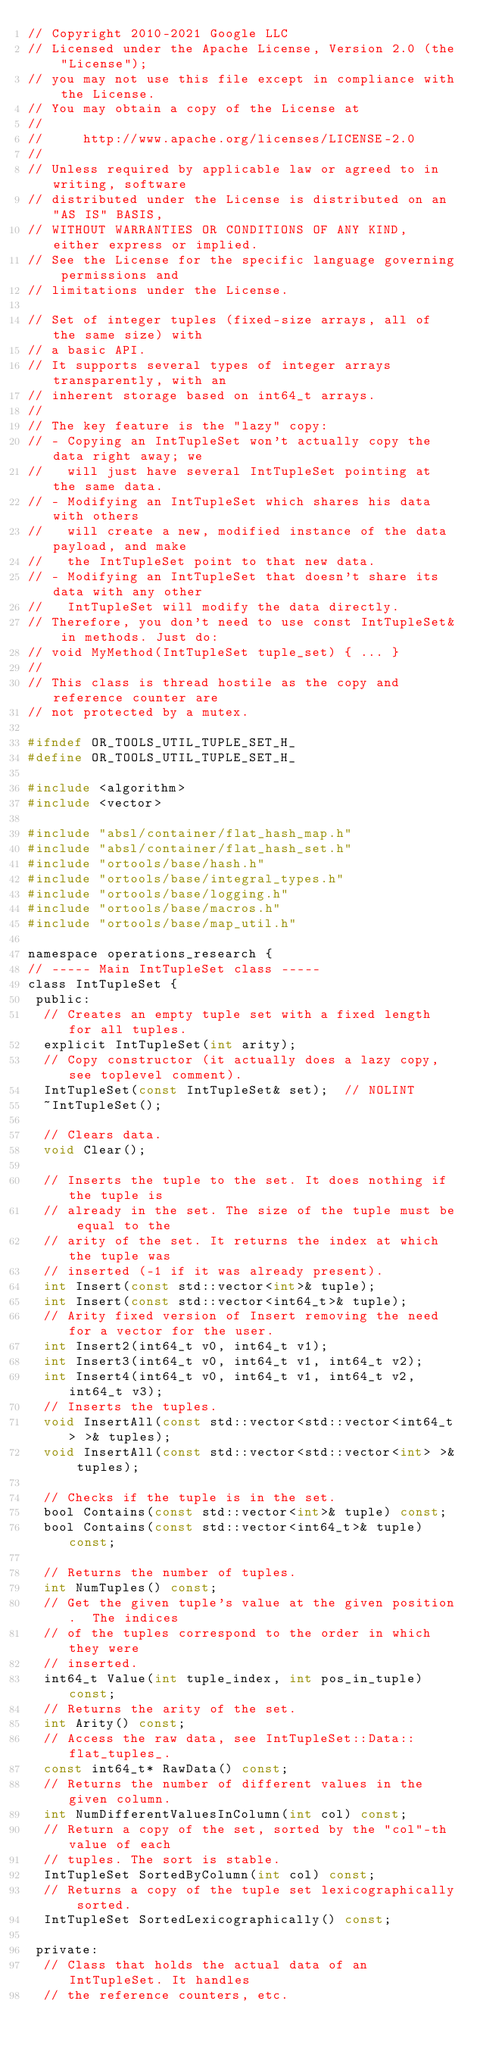<code> <loc_0><loc_0><loc_500><loc_500><_C_>// Copyright 2010-2021 Google LLC
// Licensed under the Apache License, Version 2.0 (the "License");
// you may not use this file except in compliance with the License.
// You may obtain a copy of the License at
//
//     http://www.apache.org/licenses/LICENSE-2.0
//
// Unless required by applicable law or agreed to in writing, software
// distributed under the License is distributed on an "AS IS" BASIS,
// WITHOUT WARRANTIES OR CONDITIONS OF ANY KIND, either express or implied.
// See the License for the specific language governing permissions and
// limitations under the License.

// Set of integer tuples (fixed-size arrays, all of the same size) with
// a basic API.
// It supports several types of integer arrays transparently, with an
// inherent storage based on int64_t arrays.
//
// The key feature is the "lazy" copy:
// - Copying an IntTupleSet won't actually copy the data right away; we
//   will just have several IntTupleSet pointing at the same data.
// - Modifying an IntTupleSet which shares his data with others
//   will create a new, modified instance of the data payload, and make
//   the IntTupleSet point to that new data.
// - Modifying an IntTupleSet that doesn't share its data with any other
//   IntTupleSet will modify the data directly.
// Therefore, you don't need to use const IntTupleSet& in methods. Just do:
// void MyMethod(IntTupleSet tuple_set) { ... }
//
// This class is thread hostile as the copy and reference counter are
// not protected by a mutex.

#ifndef OR_TOOLS_UTIL_TUPLE_SET_H_
#define OR_TOOLS_UTIL_TUPLE_SET_H_

#include <algorithm>
#include <vector>

#include "absl/container/flat_hash_map.h"
#include "absl/container/flat_hash_set.h"
#include "ortools/base/hash.h"
#include "ortools/base/integral_types.h"
#include "ortools/base/logging.h"
#include "ortools/base/macros.h"
#include "ortools/base/map_util.h"

namespace operations_research {
// ----- Main IntTupleSet class -----
class IntTupleSet {
 public:
  // Creates an empty tuple set with a fixed length for all tuples.
  explicit IntTupleSet(int arity);
  // Copy constructor (it actually does a lazy copy, see toplevel comment).
  IntTupleSet(const IntTupleSet& set);  // NOLINT
  ~IntTupleSet();

  // Clears data.
  void Clear();

  // Inserts the tuple to the set. It does nothing if the tuple is
  // already in the set. The size of the tuple must be equal to the
  // arity of the set. It returns the index at which the tuple was
  // inserted (-1 if it was already present).
  int Insert(const std::vector<int>& tuple);
  int Insert(const std::vector<int64_t>& tuple);
  // Arity fixed version of Insert removing the need for a vector for the user.
  int Insert2(int64_t v0, int64_t v1);
  int Insert3(int64_t v0, int64_t v1, int64_t v2);
  int Insert4(int64_t v0, int64_t v1, int64_t v2, int64_t v3);
  // Inserts the tuples.
  void InsertAll(const std::vector<std::vector<int64_t> >& tuples);
  void InsertAll(const std::vector<std::vector<int> >& tuples);

  // Checks if the tuple is in the set.
  bool Contains(const std::vector<int>& tuple) const;
  bool Contains(const std::vector<int64_t>& tuple) const;

  // Returns the number of tuples.
  int NumTuples() const;
  // Get the given tuple's value at the given position.  The indices
  // of the tuples correspond to the order in which they were
  // inserted.
  int64_t Value(int tuple_index, int pos_in_tuple) const;
  // Returns the arity of the set.
  int Arity() const;
  // Access the raw data, see IntTupleSet::Data::flat_tuples_.
  const int64_t* RawData() const;
  // Returns the number of different values in the given column.
  int NumDifferentValuesInColumn(int col) const;
  // Return a copy of the set, sorted by the "col"-th value of each
  // tuples. The sort is stable.
  IntTupleSet SortedByColumn(int col) const;
  // Returns a copy of the tuple set lexicographically sorted.
  IntTupleSet SortedLexicographically() const;

 private:
  // Class that holds the actual data of an IntTupleSet. It handles
  // the reference counters, etc.</code> 